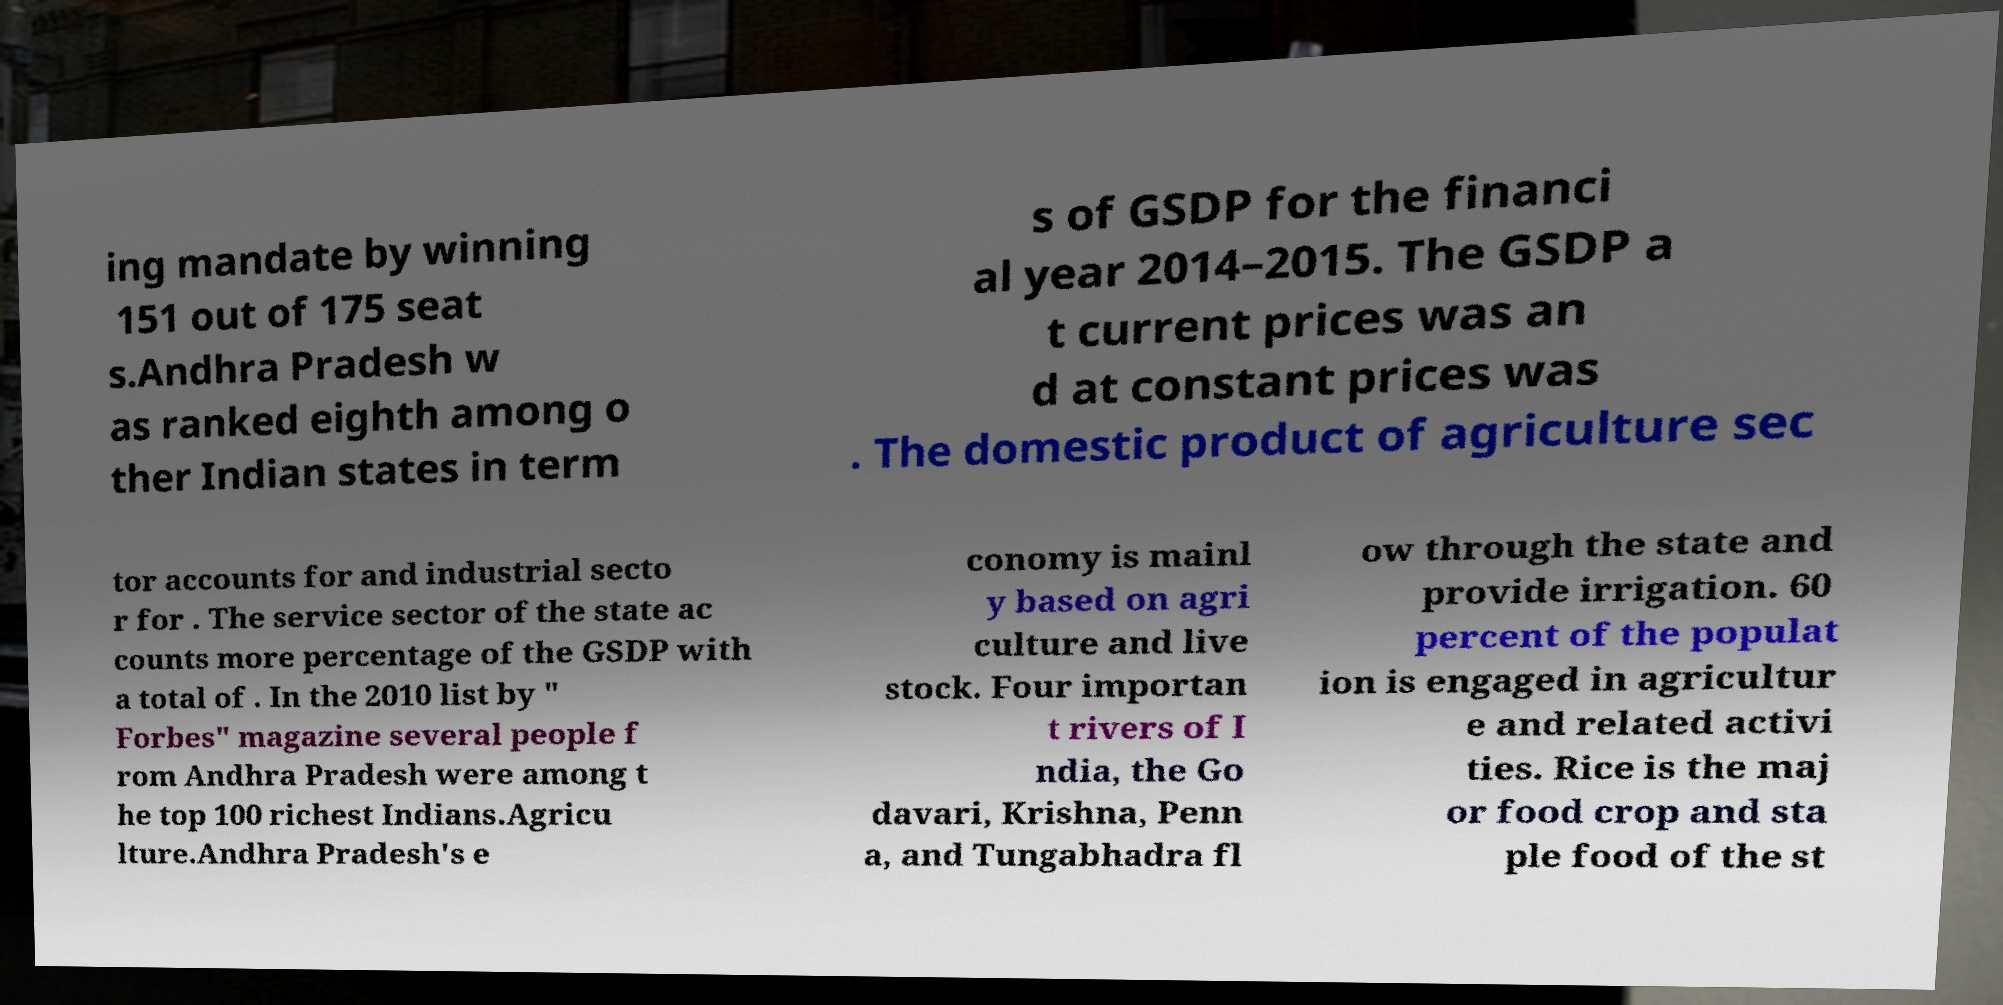I need the written content from this picture converted into text. Can you do that? ing mandate by winning 151 out of 175 seat s.Andhra Pradesh w as ranked eighth among o ther Indian states in term s of GSDP for the financi al year 2014–2015. The GSDP a t current prices was an d at constant prices was . The domestic product of agriculture sec tor accounts for and industrial secto r for . The service sector of the state ac counts more percentage of the GSDP with a total of . In the 2010 list by " Forbes" magazine several people f rom Andhra Pradesh were among t he top 100 richest Indians.Agricu lture.Andhra Pradesh's e conomy is mainl y based on agri culture and live stock. Four importan t rivers of I ndia, the Go davari, Krishna, Penn a, and Tungabhadra fl ow through the state and provide irrigation. 60 percent of the populat ion is engaged in agricultur e and related activi ties. Rice is the maj or food crop and sta ple food of the st 